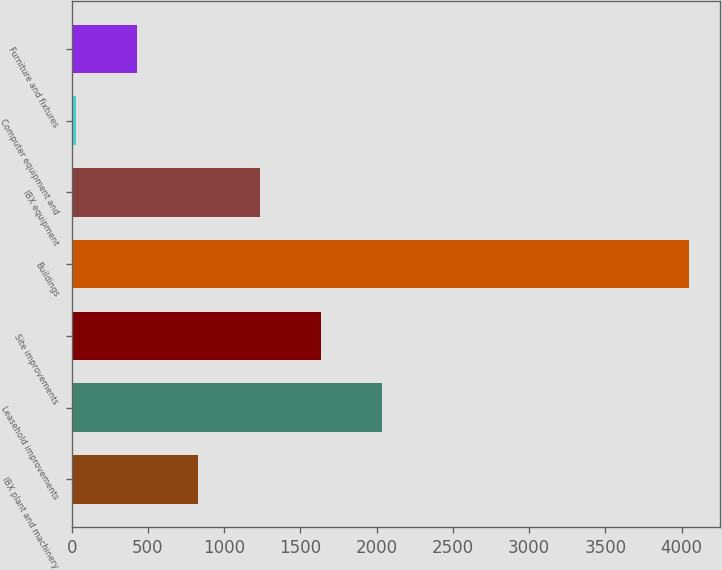Convert chart. <chart><loc_0><loc_0><loc_500><loc_500><bar_chart><fcel>IBX plant and machinery<fcel>Leasehold improvements<fcel>Site improvements<fcel>Buildings<fcel>IBX equipment<fcel>Computer equipment and<fcel>Furniture and fixtures<nl><fcel>830<fcel>2037.5<fcel>1635<fcel>4050<fcel>1232.5<fcel>25<fcel>427.5<nl></chart> 